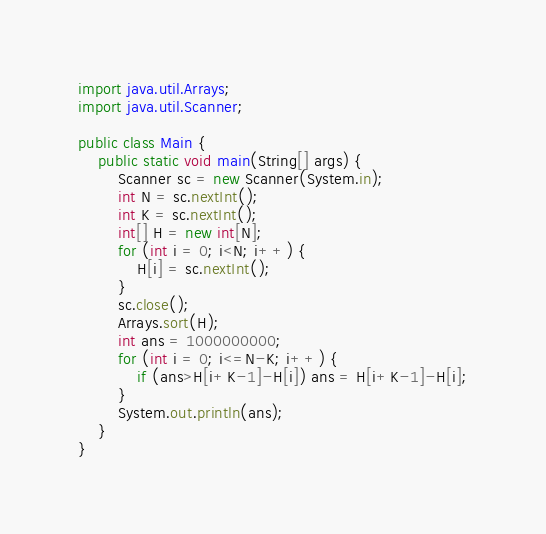<code> <loc_0><loc_0><loc_500><loc_500><_Java_>import java.util.Arrays;
import java.util.Scanner;

public class Main {
    public static void main(String[] args) {
        Scanner sc = new Scanner(System.in);
        int N = sc.nextInt();
        int K = sc.nextInt();
        int[] H = new int[N];
        for (int i = 0; i<N; i++) {
            H[i] = sc.nextInt();
        }
        sc.close();
        Arrays.sort(H);
        int ans = 1000000000;
        for (int i = 0; i<=N-K; i++) {
            if (ans>H[i+K-1]-H[i]) ans = H[i+K-1]-H[i];
        }
        System.out.println(ans);
    }
}</code> 